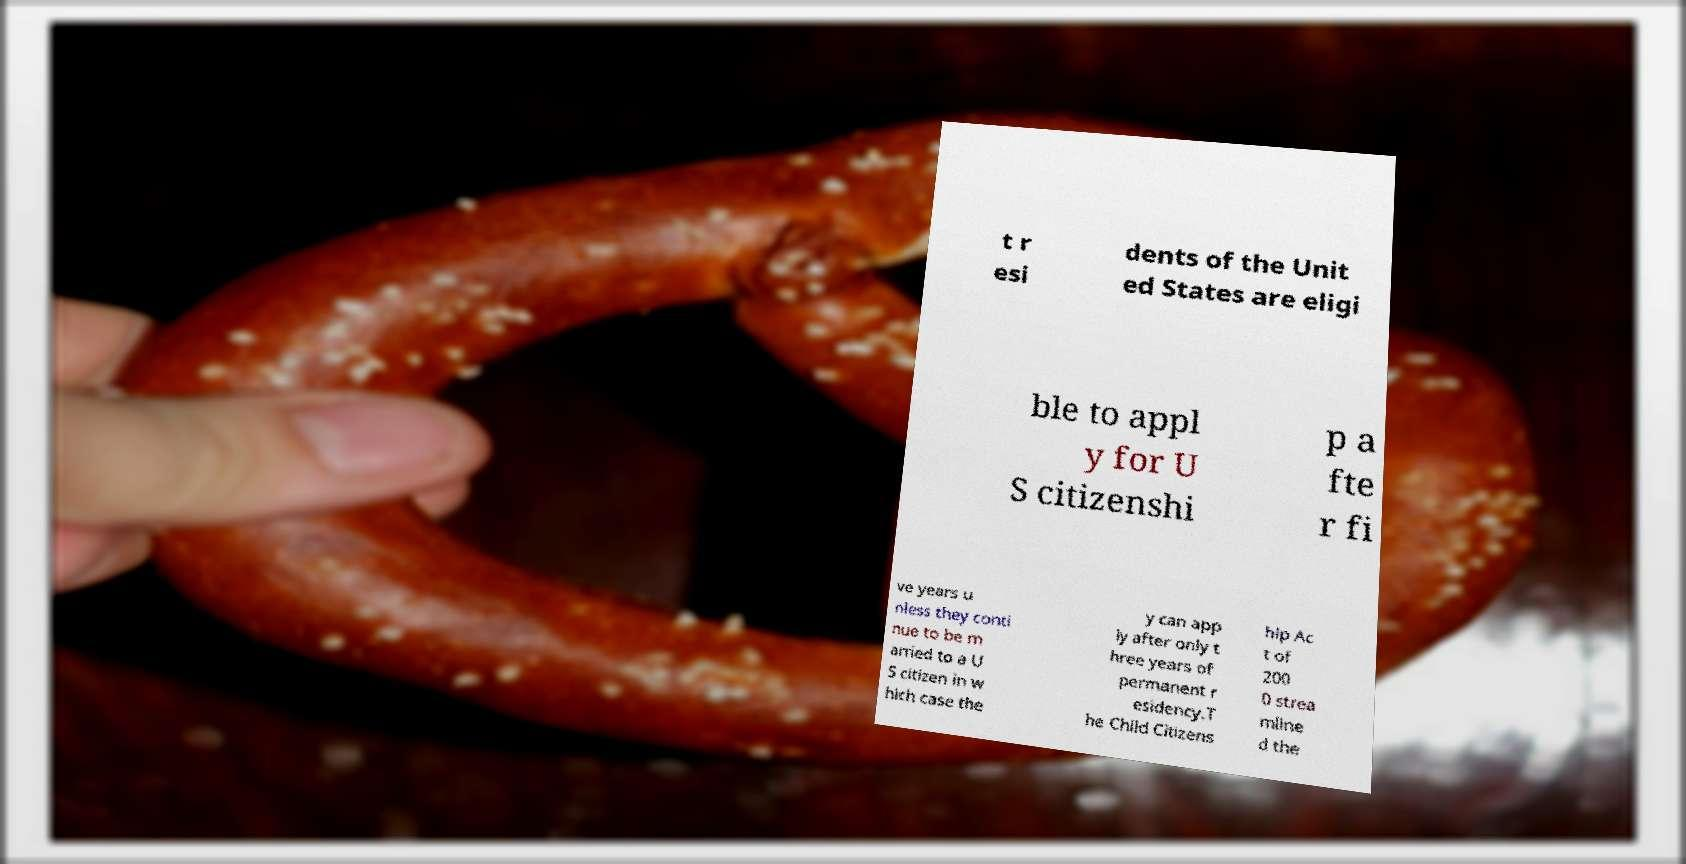Could you assist in decoding the text presented in this image and type it out clearly? t r esi dents of the Unit ed States are eligi ble to appl y for U S citizenshi p a fte r fi ve years u nless they conti nue to be m arried to a U S citizen in w hich case the y can app ly after only t hree years of permanent r esidency.T he Child Citizens hip Ac t of 200 0 strea mline d the 